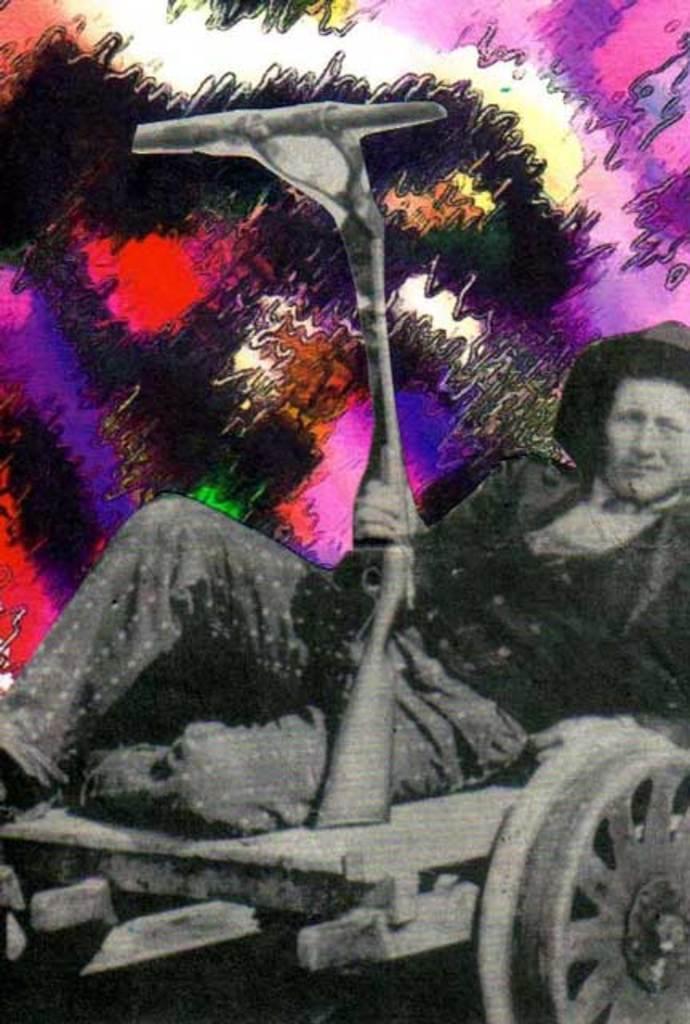In one or two sentences, can you explain what this image depicts? This is an animation in this image there is one person who is laying on a vehicle, and he is holding a gun. 